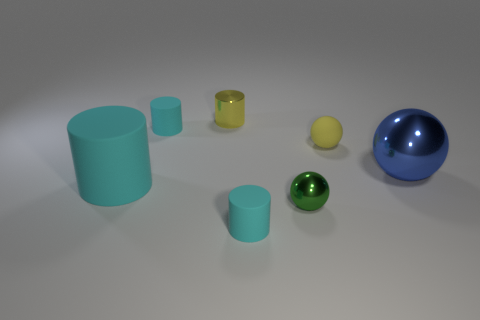Subtract all yellow balls. How many cyan cylinders are left? 3 Add 1 gray matte balls. How many objects exist? 8 Subtract all brown spheres. Subtract all blue blocks. How many spheres are left? 3 Subtract all cylinders. How many objects are left? 3 Add 1 large blue things. How many large blue things exist? 2 Subtract 0 blue cylinders. How many objects are left? 7 Subtract all small purple cubes. Subtract all balls. How many objects are left? 4 Add 4 tiny spheres. How many tiny spheres are left? 6 